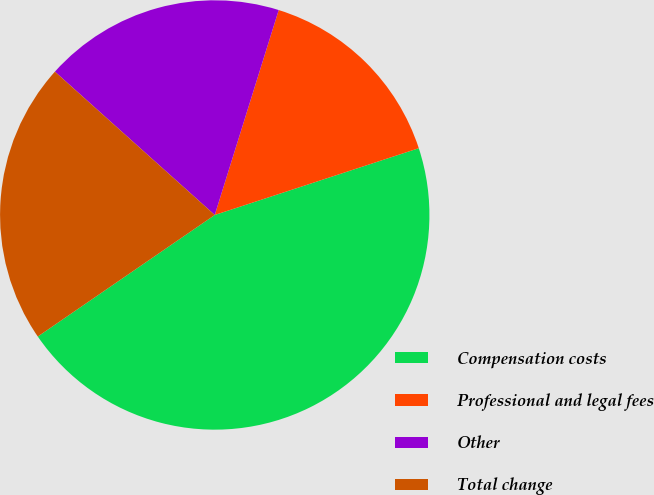<chart> <loc_0><loc_0><loc_500><loc_500><pie_chart><fcel>Compensation costs<fcel>Professional and legal fees<fcel>Other<fcel>Total change<nl><fcel>45.45%<fcel>15.15%<fcel>18.18%<fcel>21.21%<nl></chart> 